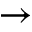<formula> <loc_0><loc_0><loc_500><loc_500>\rightarrow</formula> 